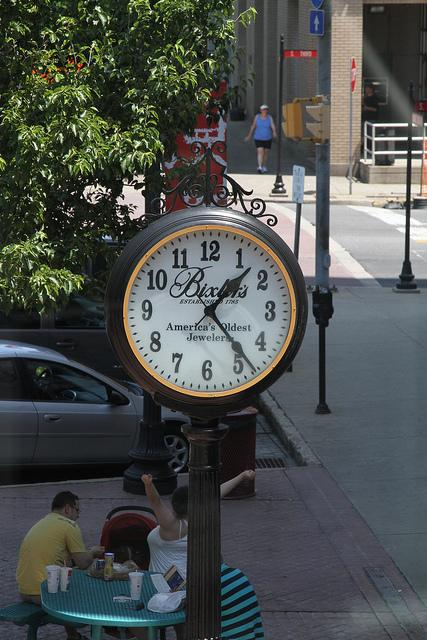What is the highest number that is visible? Please explain your reasoning. 12. Twelve is the highest number. 